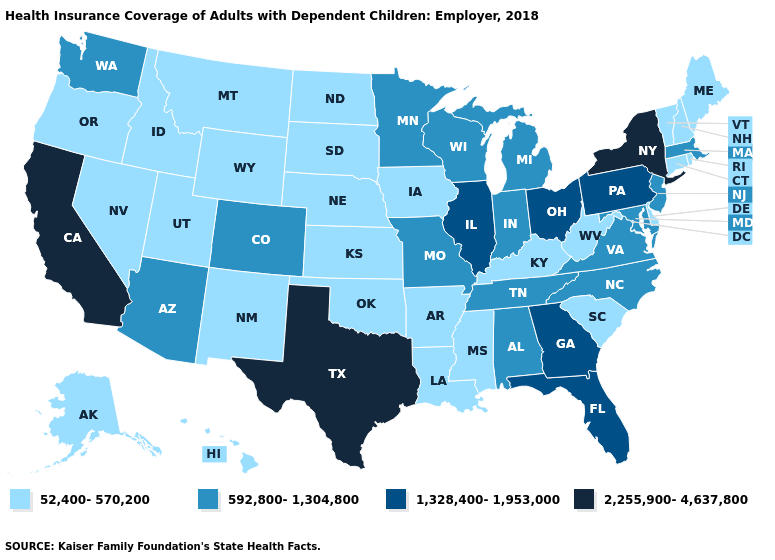What is the highest value in the West ?
Write a very short answer. 2,255,900-4,637,800. Name the states that have a value in the range 1,328,400-1,953,000?
Concise answer only. Florida, Georgia, Illinois, Ohio, Pennsylvania. Among the states that border Illinois , which have the highest value?
Short answer required. Indiana, Missouri, Wisconsin. Name the states that have a value in the range 1,328,400-1,953,000?
Quick response, please. Florida, Georgia, Illinois, Ohio, Pennsylvania. Name the states that have a value in the range 592,800-1,304,800?
Quick response, please. Alabama, Arizona, Colorado, Indiana, Maryland, Massachusetts, Michigan, Minnesota, Missouri, New Jersey, North Carolina, Tennessee, Virginia, Washington, Wisconsin. What is the value of Nevada?
Be succinct. 52,400-570,200. What is the value of Alaska?
Answer briefly. 52,400-570,200. What is the value of New Hampshire?
Give a very brief answer. 52,400-570,200. What is the value of South Dakota?
Short answer required. 52,400-570,200. What is the lowest value in the Northeast?
Answer briefly. 52,400-570,200. What is the lowest value in the USA?
Write a very short answer. 52,400-570,200. Which states have the lowest value in the USA?
Keep it brief. Alaska, Arkansas, Connecticut, Delaware, Hawaii, Idaho, Iowa, Kansas, Kentucky, Louisiana, Maine, Mississippi, Montana, Nebraska, Nevada, New Hampshire, New Mexico, North Dakota, Oklahoma, Oregon, Rhode Island, South Carolina, South Dakota, Utah, Vermont, West Virginia, Wyoming. Among the states that border Indiana , which have the lowest value?
Concise answer only. Kentucky. What is the value of South Dakota?
Short answer required. 52,400-570,200. How many symbols are there in the legend?
Write a very short answer. 4. 